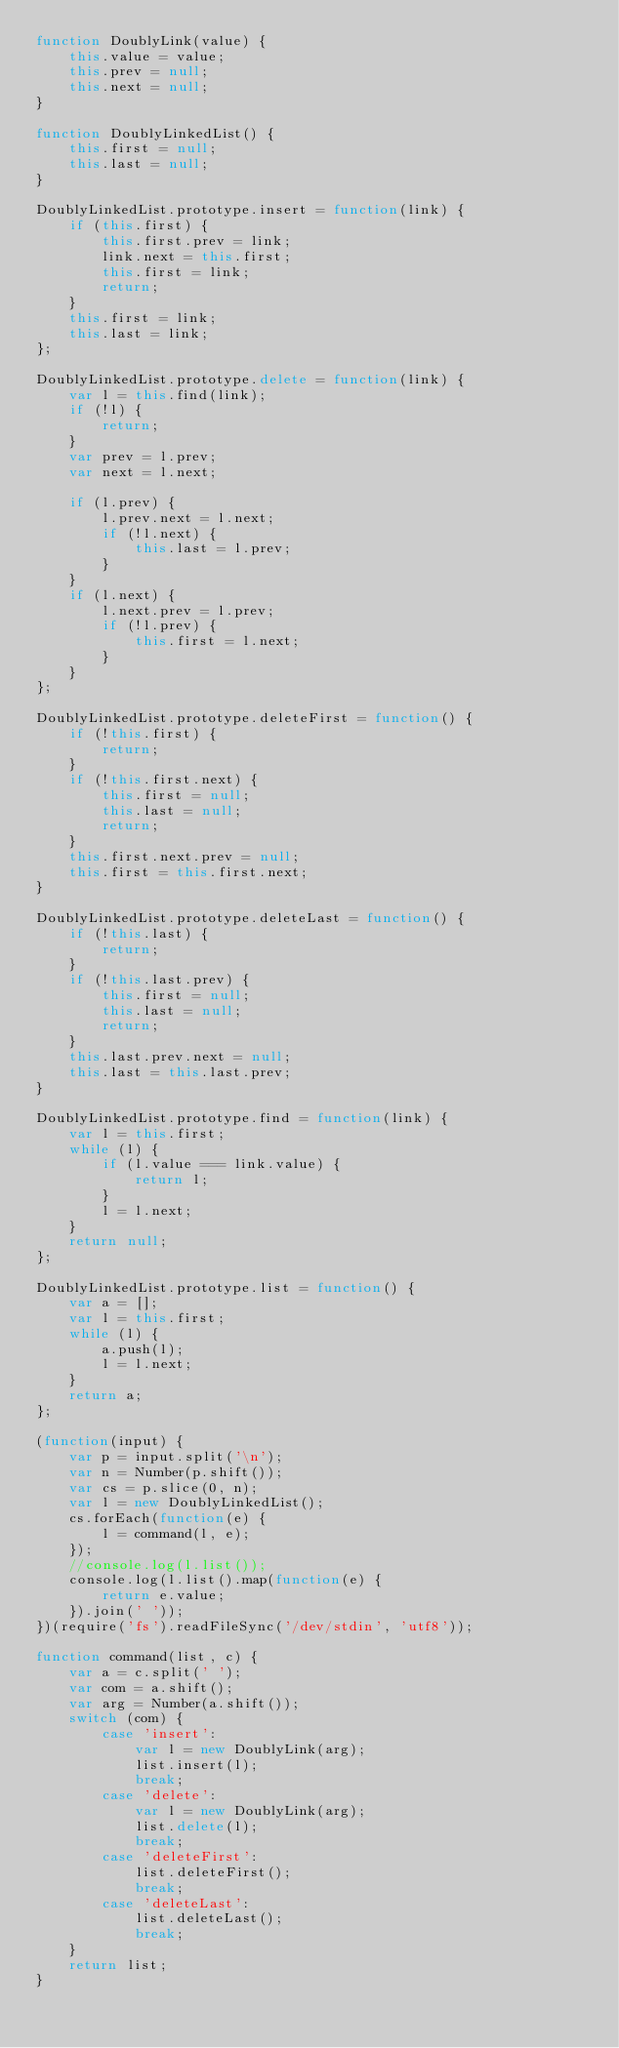<code> <loc_0><loc_0><loc_500><loc_500><_JavaScript_>function DoublyLink(value) {
    this.value = value;
    this.prev = null;
    this.next = null;
}

function DoublyLinkedList() {
    this.first = null;
    this.last = null;
}

DoublyLinkedList.prototype.insert = function(link) {
    if (this.first) {
        this.first.prev = link;
        link.next = this.first;
        this.first = link;
        return;
    }
    this.first = link;
    this.last = link;
};

DoublyLinkedList.prototype.delete = function(link) {
    var l = this.find(link);
    if (!l) {
        return;
    }
    var prev = l.prev;
    var next = l.next;

    if (l.prev) {
        l.prev.next = l.next;
        if (!l.next) {
            this.last = l.prev;
        }
    }
    if (l.next) {
        l.next.prev = l.prev;
        if (!l.prev) {
            this.first = l.next;
        }
    }
};

DoublyLinkedList.prototype.deleteFirst = function() {
    if (!this.first) {
        return;
    }
    if (!this.first.next) {
        this.first = null;
        this.last = null;
        return;
    }
    this.first.next.prev = null;
    this.first = this.first.next;
}

DoublyLinkedList.prototype.deleteLast = function() {
    if (!this.last) {
        return;
    }
    if (!this.last.prev) {
        this.first = null;
        this.last = null;
        return;
    }
    this.last.prev.next = null;
    this.last = this.last.prev;
}

DoublyLinkedList.prototype.find = function(link) {
    var l = this.first;
    while (l) {
        if (l.value === link.value) {
            return l;
        }
        l = l.next;
    }
    return null;
};

DoublyLinkedList.prototype.list = function() {
    var a = [];
    var l = this.first;
    while (l) {
        a.push(l);
        l = l.next;
    }
    return a;
};

(function(input) {
    var p = input.split('\n');
    var n = Number(p.shift());
    var cs = p.slice(0, n);
    var l = new DoublyLinkedList();
    cs.forEach(function(e) {
        l = command(l, e);
    });
    //console.log(l.list());
    console.log(l.list().map(function(e) {
        return e.value;
    }).join(' '));
})(require('fs').readFileSync('/dev/stdin', 'utf8'));

function command(list, c) {
    var a = c.split(' ');
    var com = a.shift();
    var arg = Number(a.shift());
    switch (com) {
        case 'insert':
            var l = new DoublyLink(arg);
            list.insert(l);
            break;
        case 'delete':
            var l = new DoublyLink(arg);
            list.delete(l);
            break;
        case 'deleteFirst':
            list.deleteFirst();
            break;
        case 'deleteLast':
            list.deleteLast();
            break;
    }
    return list;
}</code> 